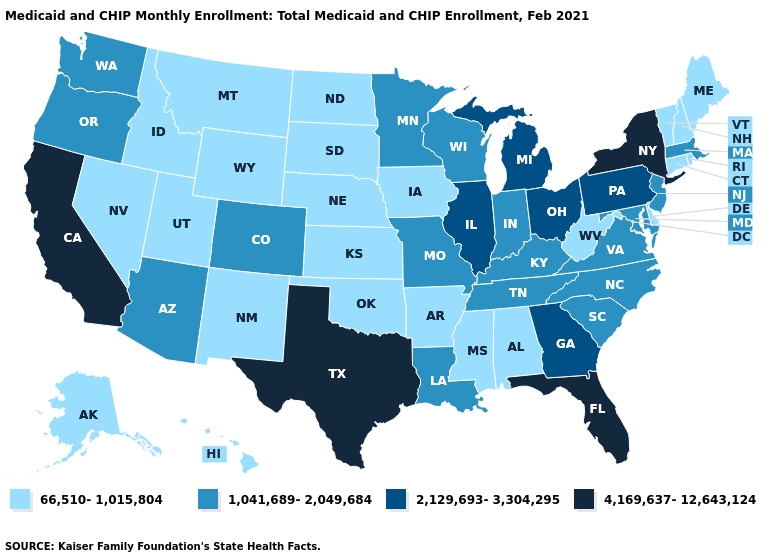How many symbols are there in the legend?
Write a very short answer. 4. Name the states that have a value in the range 4,169,637-12,643,124?
Answer briefly. California, Florida, New York, Texas. Does the first symbol in the legend represent the smallest category?
Quick response, please. Yes. How many symbols are there in the legend?
Short answer required. 4. What is the value of Delaware?
Be succinct. 66,510-1,015,804. What is the value of Idaho?
Give a very brief answer. 66,510-1,015,804. Name the states that have a value in the range 4,169,637-12,643,124?
Concise answer only. California, Florida, New York, Texas. What is the lowest value in states that border Vermont?
Write a very short answer. 66,510-1,015,804. What is the value of Nevada?
Be succinct. 66,510-1,015,804. Among the states that border Iowa , does Missouri have the highest value?
Concise answer only. No. Which states hav the highest value in the South?
Short answer required. Florida, Texas. What is the value of Nevada?
Keep it brief. 66,510-1,015,804. What is the value of Nebraska?
Keep it brief. 66,510-1,015,804. What is the lowest value in the USA?
Keep it brief. 66,510-1,015,804. Does Colorado have the same value as Oklahoma?
Be succinct. No. 